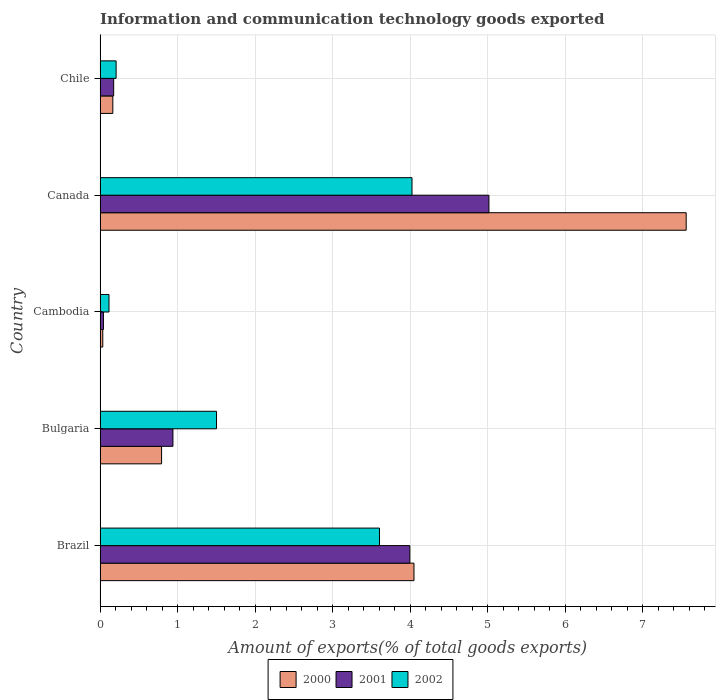Are the number of bars per tick equal to the number of legend labels?
Ensure brevity in your answer.  Yes. How many bars are there on the 4th tick from the top?
Keep it short and to the point. 3. How many bars are there on the 5th tick from the bottom?
Offer a very short reply. 3. In how many cases, is the number of bars for a given country not equal to the number of legend labels?
Give a very brief answer. 0. What is the amount of goods exported in 2000 in Canada?
Make the answer very short. 7.56. Across all countries, what is the maximum amount of goods exported in 2000?
Ensure brevity in your answer.  7.56. Across all countries, what is the minimum amount of goods exported in 2000?
Your answer should be compact. 0.04. In which country was the amount of goods exported in 2002 minimum?
Your answer should be very brief. Cambodia. What is the total amount of goods exported in 2002 in the graph?
Keep it short and to the point. 9.45. What is the difference between the amount of goods exported in 2001 in Brazil and that in Cambodia?
Your answer should be compact. 3.95. What is the difference between the amount of goods exported in 2000 in Bulgaria and the amount of goods exported in 2001 in Cambodia?
Provide a succinct answer. 0.75. What is the average amount of goods exported in 2002 per country?
Provide a short and direct response. 1.89. What is the difference between the amount of goods exported in 2000 and amount of goods exported in 2002 in Chile?
Your answer should be very brief. -0.04. In how many countries, is the amount of goods exported in 2000 greater than 4.4 %?
Your response must be concise. 1. What is the ratio of the amount of goods exported in 2001 in Bulgaria to that in Canada?
Your answer should be compact. 0.19. Is the amount of goods exported in 2000 in Bulgaria less than that in Cambodia?
Offer a very short reply. No. Is the difference between the amount of goods exported in 2000 in Brazil and Cambodia greater than the difference between the amount of goods exported in 2002 in Brazil and Cambodia?
Ensure brevity in your answer.  Yes. What is the difference between the highest and the second highest amount of goods exported in 2000?
Provide a short and direct response. 3.51. What is the difference between the highest and the lowest amount of goods exported in 2002?
Ensure brevity in your answer.  3.91. In how many countries, is the amount of goods exported in 2002 greater than the average amount of goods exported in 2002 taken over all countries?
Your answer should be very brief. 2. What does the 3rd bar from the bottom in Brazil represents?
Provide a succinct answer. 2002. How many bars are there?
Provide a short and direct response. 15. What is the title of the graph?
Keep it short and to the point. Information and communication technology goods exported. What is the label or title of the X-axis?
Your response must be concise. Amount of exports(% of total goods exports). What is the Amount of exports(% of total goods exports) in 2000 in Brazil?
Make the answer very short. 4.05. What is the Amount of exports(% of total goods exports) of 2001 in Brazil?
Offer a terse response. 4. What is the Amount of exports(% of total goods exports) of 2002 in Brazil?
Your response must be concise. 3.6. What is the Amount of exports(% of total goods exports) of 2000 in Bulgaria?
Provide a succinct answer. 0.79. What is the Amount of exports(% of total goods exports) in 2001 in Bulgaria?
Ensure brevity in your answer.  0.94. What is the Amount of exports(% of total goods exports) of 2002 in Bulgaria?
Your answer should be very brief. 1.5. What is the Amount of exports(% of total goods exports) in 2000 in Cambodia?
Give a very brief answer. 0.04. What is the Amount of exports(% of total goods exports) in 2001 in Cambodia?
Keep it short and to the point. 0.04. What is the Amount of exports(% of total goods exports) in 2002 in Cambodia?
Provide a succinct answer. 0.12. What is the Amount of exports(% of total goods exports) in 2000 in Canada?
Your response must be concise. 7.56. What is the Amount of exports(% of total goods exports) in 2001 in Canada?
Provide a succinct answer. 5.02. What is the Amount of exports(% of total goods exports) of 2002 in Canada?
Offer a terse response. 4.02. What is the Amount of exports(% of total goods exports) in 2000 in Chile?
Offer a terse response. 0.16. What is the Amount of exports(% of total goods exports) in 2001 in Chile?
Offer a very short reply. 0.18. What is the Amount of exports(% of total goods exports) in 2002 in Chile?
Make the answer very short. 0.21. Across all countries, what is the maximum Amount of exports(% of total goods exports) in 2000?
Give a very brief answer. 7.56. Across all countries, what is the maximum Amount of exports(% of total goods exports) of 2001?
Your answer should be compact. 5.02. Across all countries, what is the maximum Amount of exports(% of total goods exports) of 2002?
Your response must be concise. 4.02. Across all countries, what is the minimum Amount of exports(% of total goods exports) in 2000?
Offer a very short reply. 0.04. Across all countries, what is the minimum Amount of exports(% of total goods exports) in 2001?
Provide a succinct answer. 0.04. Across all countries, what is the minimum Amount of exports(% of total goods exports) of 2002?
Provide a short and direct response. 0.12. What is the total Amount of exports(% of total goods exports) in 2000 in the graph?
Offer a very short reply. 12.6. What is the total Amount of exports(% of total goods exports) of 2001 in the graph?
Make the answer very short. 10.17. What is the total Amount of exports(% of total goods exports) in 2002 in the graph?
Offer a very short reply. 9.45. What is the difference between the Amount of exports(% of total goods exports) in 2000 in Brazil and that in Bulgaria?
Offer a terse response. 3.26. What is the difference between the Amount of exports(% of total goods exports) in 2001 in Brazil and that in Bulgaria?
Give a very brief answer. 3.06. What is the difference between the Amount of exports(% of total goods exports) of 2002 in Brazil and that in Bulgaria?
Ensure brevity in your answer.  2.1. What is the difference between the Amount of exports(% of total goods exports) in 2000 in Brazil and that in Cambodia?
Offer a very short reply. 4.01. What is the difference between the Amount of exports(% of total goods exports) in 2001 in Brazil and that in Cambodia?
Provide a short and direct response. 3.95. What is the difference between the Amount of exports(% of total goods exports) of 2002 in Brazil and that in Cambodia?
Make the answer very short. 3.49. What is the difference between the Amount of exports(% of total goods exports) of 2000 in Brazil and that in Canada?
Your answer should be very brief. -3.51. What is the difference between the Amount of exports(% of total goods exports) in 2001 in Brazil and that in Canada?
Keep it short and to the point. -1.02. What is the difference between the Amount of exports(% of total goods exports) of 2002 in Brazil and that in Canada?
Provide a short and direct response. -0.42. What is the difference between the Amount of exports(% of total goods exports) in 2000 in Brazil and that in Chile?
Your answer should be very brief. 3.88. What is the difference between the Amount of exports(% of total goods exports) of 2001 in Brazil and that in Chile?
Offer a terse response. 3.82. What is the difference between the Amount of exports(% of total goods exports) of 2002 in Brazil and that in Chile?
Your answer should be very brief. 3.4. What is the difference between the Amount of exports(% of total goods exports) in 2000 in Bulgaria and that in Cambodia?
Provide a short and direct response. 0.76. What is the difference between the Amount of exports(% of total goods exports) in 2001 in Bulgaria and that in Cambodia?
Ensure brevity in your answer.  0.9. What is the difference between the Amount of exports(% of total goods exports) of 2002 in Bulgaria and that in Cambodia?
Your response must be concise. 1.39. What is the difference between the Amount of exports(% of total goods exports) of 2000 in Bulgaria and that in Canada?
Provide a short and direct response. -6.77. What is the difference between the Amount of exports(% of total goods exports) in 2001 in Bulgaria and that in Canada?
Ensure brevity in your answer.  -4.08. What is the difference between the Amount of exports(% of total goods exports) of 2002 in Bulgaria and that in Canada?
Provide a short and direct response. -2.52. What is the difference between the Amount of exports(% of total goods exports) of 2000 in Bulgaria and that in Chile?
Ensure brevity in your answer.  0.63. What is the difference between the Amount of exports(% of total goods exports) of 2001 in Bulgaria and that in Chile?
Make the answer very short. 0.76. What is the difference between the Amount of exports(% of total goods exports) in 2002 in Bulgaria and that in Chile?
Offer a very short reply. 1.29. What is the difference between the Amount of exports(% of total goods exports) in 2000 in Cambodia and that in Canada?
Provide a short and direct response. -7.53. What is the difference between the Amount of exports(% of total goods exports) in 2001 in Cambodia and that in Canada?
Offer a terse response. -4.97. What is the difference between the Amount of exports(% of total goods exports) in 2002 in Cambodia and that in Canada?
Your answer should be compact. -3.91. What is the difference between the Amount of exports(% of total goods exports) in 2000 in Cambodia and that in Chile?
Your answer should be very brief. -0.13. What is the difference between the Amount of exports(% of total goods exports) in 2001 in Cambodia and that in Chile?
Keep it short and to the point. -0.13. What is the difference between the Amount of exports(% of total goods exports) of 2002 in Cambodia and that in Chile?
Provide a short and direct response. -0.09. What is the difference between the Amount of exports(% of total goods exports) of 2000 in Canada and that in Chile?
Make the answer very short. 7.4. What is the difference between the Amount of exports(% of total goods exports) of 2001 in Canada and that in Chile?
Your answer should be very brief. 4.84. What is the difference between the Amount of exports(% of total goods exports) in 2002 in Canada and that in Chile?
Give a very brief answer. 3.82. What is the difference between the Amount of exports(% of total goods exports) of 2000 in Brazil and the Amount of exports(% of total goods exports) of 2001 in Bulgaria?
Ensure brevity in your answer.  3.11. What is the difference between the Amount of exports(% of total goods exports) in 2000 in Brazil and the Amount of exports(% of total goods exports) in 2002 in Bulgaria?
Your answer should be compact. 2.55. What is the difference between the Amount of exports(% of total goods exports) of 2001 in Brazil and the Amount of exports(% of total goods exports) of 2002 in Bulgaria?
Offer a terse response. 2.49. What is the difference between the Amount of exports(% of total goods exports) of 2000 in Brazil and the Amount of exports(% of total goods exports) of 2001 in Cambodia?
Ensure brevity in your answer.  4.01. What is the difference between the Amount of exports(% of total goods exports) in 2000 in Brazil and the Amount of exports(% of total goods exports) in 2002 in Cambodia?
Offer a very short reply. 3.93. What is the difference between the Amount of exports(% of total goods exports) in 2001 in Brazil and the Amount of exports(% of total goods exports) in 2002 in Cambodia?
Your response must be concise. 3.88. What is the difference between the Amount of exports(% of total goods exports) in 2000 in Brazil and the Amount of exports(% of total goods exports) in 2001 in Canada?
Give a very brief answer. -0.97. What is the difference between the Amount of exports(% of total goods exports) in 2000 in Brazil and the Amount of exports(% of total goods exports) in 2002 in Canada?
Your answer should be very brief. 0.03. What is the difference between the Amount of exports(% of total goods exports) of 2001 in Brazil and the Amount of exports(% of total goods exports) of 2002 in Canada?
Your answer should be very brief. -0.03. What is the difference between the Amount of exports(% of total goods exports) in 2000 in Brazil and the Amount of exports(% of total goods exports) in 2001 in Chile?
Offer a terse response. 3.87. What is the difference between the Amount of exports(% of total goods exports) of 2000 in Brazil and the Amount of exports(% of total goods exports) of 2002 in Chile?
Provide a short and direct response. 3.84. What is the difference between the Amount of exports(% of total goods exports) in 2001 in Brazil and the Amount of exports(% of total goods exports) in 2002 in Chile?
Your answer should be compact. 3.79. What is the difference between the Amount of exports(% of total goods exports) in 2000 in Bulgaria and the Amount of exports(% of total goods exports) in 2001 in Cambodia?
Make the answer very short. 0.75. What is the difference between the Amount of exports(% of total goods exports) in 2000 in Bulgaria and the Amount of exports(% of total goods exports) in 2002 in Cambodia?
Make the answer very short. 0.68. What is the difference between the Amount of exports(% of total goods exports) in 2001 in Bulgaria and the Amount of exports(% of total goods exports) in 2002 in Cambodia?
Offer a terse response. 0.82. What is the difference between the Amount of exports(% of total goods exports) of 2000 in Bulgaria and the Amount of exports(% of total goods exports) of 2001 in Canada?
Offer a very short reply. -4.22. What is the difference between the Amount of exports(% of total goods exports) in 2000 in Bulgaria and the Amount of exports(% of total goods exports) in 2002 in Canada?
Provide a succinct answer. -3.23. What is the difference between the Amount of exports(% of total goods exports) in 2001 in Bulgaria and the Amount of exports(% of total goods exports) in 2002 in Canada?
Your response must be concise. -3.08. What is the difference between the Amount of exports(% of total goods exports) of 2000 in Bulgaria and the Amount of exports(% of total goods exports) of 2001 in Chile?
Ensure brevity in your answer.  0.62. What is the difference between the Amount of exports(% of total goods exports) in 2000 in Bulgaria and the Amount of exports(% of total goods exports) in 2002 in Chile?
Keep it short and to the point. 0.59. What is the difference between the Amount of exports(% of total goods exports) in 2001 in Bulgaria and the Amount of exports(% of total goods exports) in 2002 in Chile?
Your response must be concise. 0.73. What is the difference between the Amount of exports(% of total goods exports) in 2000 in Cambodia and the Amount of exports(% of total goods exports) in 2001 in Canada?
Keep it short and to the point. -4.98. What is the difference between the Amount of exports(% of total goods exports) in 2000 in Cambodia and the Amount of exports(% of total goods exports) in 2002 in Canada?
Give a very brief answer. -3.99. What is the difference between the Amount of exports(% of total goods exports) of 2001 in Cambodia and the Amount of exports(% of total goods exports) of 2002 in Canada?
Your answer should be compact. -3.98. What is the difference between the Amount of exports(% of total goods exports) of 2000 in Cambodia and the Amount of exports(% of total goods exports) of 2001 in Chile?
Offer a terse response. -0.14. What is the difference between the Amount of exports(% of total goods exports) of 2000 in Cambodia and the Amount of exports(% of total goods exports) of 2002 in Chile?
Keep it short and to the point. -0.17. What is the difference between the Amount of exports(% of total goods exports) in 2001 in Cambodia and the Amount of exports(% of total goods exports) in 2002 in Chile?
Ensure brevity in your answer.  -0.16. What is the difference between the Amount of exports(% of total goods exports) of 2000 in Canada and the Amount of exports(% of total goods exports) of 2001 in Chile?
Ensure brevity in your answer.  7.38. What is the difference between the Amount of exports(% of total goods exports) of 2000 in Canada and the Amount of exports(% of total goods exports) of 2002 in Chile?
Offer a terse response. 7.35. What is the difference between the Amount of exports(% of total goods exports) in 2001 in Canada and the Amount of exports(% of total goods exports) in 2002 in Chile?
Offer a terse response. 4.81. What is the average Amount of exports(% of total goods exports) of 2000 per country?
Your answer should be compact. 2.52. What is the average Amount of exports(% of total goods exports) in 2001 per country?
Your answer should be compact. 2.03. What is the average Amount of exports(% of total goods exports) of 2002 per country?
Your answer should be compact. 1.89. What is the difference between the Amount of exports(% of total goods exports) in 2000 and Amount of exports(% of total goods exports) in 2001 in Brazil?
Make the answer very short. 0.05. What is the difference between the Amount of exports(% of total goods exports) in 2000 and Amount of exports(% of total goods exports) in 2002 in Brazil?
Keep it short and to the point. 0.45. What is the difference between the Amount of exports(% of total goods exports) of 2001 and Amount of exports(% of total goods exports) of 2002 in Brazil?
Your response must be concise. 0.39. What is the difference between the Amount of exports(% of total goods exports) in 2000 and Amount of exports(% of total goods exports) in 2001 in Bulgaria?
Your answer should be very brief. -0.15. What is the difference between the Amount of exports(% of total goods exports) of 2000 and Amount of exports(% of total goods exports) of 2002 in Bulgaria?
Offer a terse response. -0.71. What is the difference between the Amount of exports(% of total goods exports) in 2001 and Amount of exports(% of total goods exports) in 2002 in Bulgaria?
Keep it short and to the point. -0.56. What is the difference between the Amount of exports(% of total goods exports) of 2000 and Amount of exports(% of total goods exports) of 2001 in Cambodia?
Provide a short and direct response. -0.01. What is the difference between the Amount of exports(% of total goods exports) of 2000 and Amount of exports(% of total goods exports) of 2002 in Cambodia?
Offer a terse response. -0.08. What is the difference between the Amount of exports(% of total goods exports) of 2001 and Amount of exports(% of total goods exports) of 2002 in Cambodia?
Your answer should be very brief. -0.07. What is the difference between the Amount of exports(% of total goods exports) of 2000 and Amount of exports(% of total goods exports) of 2001 in Canada?
Make the answer very short. 2.54. What is the difference between the Amount of exports(% of total goods exports) of 2000 and Amount of exports(% of total goods exports) of 2002 in Canada?
Ensure brevity in your answer.  3.54. What is the difference between the Amount of exports(% of total goods exports) in 2000 and Amount of exports(% of total goods exports) in 2001 in Chile?
Give a very brief answer. -0.01. What is the difference between the Amount of exports(% of total goods exports) of 2000 and Amount of exports(% of total goods exports) of 2002 in Chile?
Provide a succinct answer. -0.04. What is the difference between the Amount of exports(% of total goods exports) in 2001 and Amount of exports(% of total goods exports) in 2002 in Chile?
Your response must be concise. -0.03. What is the ratio of the Amount of exports(% of total goods exports) of 2000 in Brazil to that in Bulgaria?
Your answer should be very brief. 5.1. What is the ratio of the Amount of exports(% of total goods exports) in 2001 in Brazil to that in Bulgaria?
Provide a short and direct response. 4.25. What is the ratio of the Amount of exports(% of total goods exports) in 2002 in Brazil to that in Bulgaria?
Your response must be concise. 2.4. What is the ratio of the Amount of exports(% of total goods exports) of 2000 in Brazil to that in Cambodia?
Provide a succinct answer. 115.35. What is the ratio of the Amount of exports(% of total goods exports) in 2001 in Brazil to that in Cambodia?
Provide a succinct answer. 91.39. What is the ratio of the Amount of exports(% of total goods exports) in 2002 in Brazil to that in Cambodia?
Offer a terse response. 31.27. What is the ratio of the Amount of exports(% of total goods exports) in 2000 in Brazil to that in Canada?
Give a very brief answer. 0.54. What is the ratio of the Amount of exports(% of total goods exports) of 2001 in Brazil to that in Canada?
Your answer should be very brief. 0.8. What is the ratio of the Amount of exports(% of total goods exports) in 2002 in Brazil to that in Canada?
Offer a very short reply. 0.9. What is the ratio of the Amount of exports(% of total goods exports) of 2000 in Brazil to that in Chile?
Give a very brief answer. 24.59. What is the ratio of the Amount of exports(% of total goods exports) of 2001 in Brazil to that in Chile?
Provide a short and direct response. 22.77. What is the ratio of the Amount of exports(% of total goods exports) in 2002 in Brazil to that in Chile?
Keep it short and to the point. 17.41. What is the ratio of the Amount of exports(% of total goods exports) in 2000 in Bulgaria to that in Cambodia?
Your response must be concise. 22.6. What is the ratio of the Amount of exports(% of total goods exports) in 2001 in Bulgaria to that in Cambodia?
Keep it short and to the point. 21.5. What is the ratio of the Amount of exports(% of total goods exports) of 2002 in Bulgaria to that in Cambodia?
Provide a succinct answer. 13.03. What is the ratio of the Amount of exports(% of total goods exports) of 2000 in Bulgaria to that in Canada?
Make the answer very short. 0.1. What is the ratio of the Amount of exports(% of total goods exports) of 2001 in Bulgaria to that in Canada?
Keep it short and to the point. 0.19. What is the ratio of the Amount of exports(% of total goods exports) in 2002 in Bulgaria to that in Canada?
Your response must be concise. 0.37. What is the ratio of the Amount of exports(% of total goods exports) of 2000 in Bulgaria to that in Chile?
Make the answer very short. 4.82. What is the ratio of the Amount of exports(% of total goods exports) of 2001 in Bulgaria to that in Chile?
Ensure brevity in your answer.  5.36. What is the ratio of the Amount of exports(% of total goods exports) of 2002 in Bulgaria to that in Chile?
Ensure brevity in your answer.  7.25. What is the ratio of the Amount of exports(% of total goods exports) of 2000 in Cambodia to that in Canada?
Provide a succinct answer. 0. What is the ratio of the Amount of exports(% of total goods exports) of 2001 in Cambodia to that in Canada?
Your response must be concise. 0.01. What is the ratio of the Amount of exports(% of total goods exports) in 2002 in Cambodia to that in Canada?
Provide a short and direct response. 0.03. What is the ratio of the Amount of exports(% of total goods exports) in 2000 in Cambodia to that in Chile?
Ensure brevity in your answer.  0.21. What is the ratio of the Amount of exports(% of total goods exports) of 2001 in Cambodia to that in Chile?
Offer a terse response. 0.25. What is the ratio of the Amount of exports(% of total goods exports) in 2002 in Cambodia to that in Chile?
Ensure brevity in your answer.  0.56. What is the ratio of the Amount of exports(% of total goods exports) in 2000 in Canada to that in Chile?
Make the answer very short. 45.9. What is the ratio of the Amount of exports(% of total goods exports) of 2001 in Canada to that in Chile?
Ensure brevity in your answer.  28.58. What is the ratio of the Amount of exports(% of total goods exports) of 2002 in Canada to that in Chile?
Ensure brevity in your answer.  19.43. What is the difference between the highest and the second highest Amount of exports(% of total goods exports) in 2000?
Ensure brevity in your answer.  3.51. What is the difference between the highest and the second highest Amount of exports(% of total goods exports) in 2001?
Provide a succinct answer. 1.02. What is the difference between the highest and the second highest Amount of exports(% of total goods exports) of 2002?
Give a very brief answer. 0.42. What is the difference between the highest and the lowest Amount of exports(% of total goods exports) of 2000?
Keep it short and to the point. 7.53. What is the difference between the highest and the lowest Amount of exports(% of total goods exports) of 2001?
Provide a succinct answer. 4.97. What is the difference between the highest and the lowest Amount of exports(% of total goods exports) of 2002?
Ensure brevity in your answer.  3.91. 